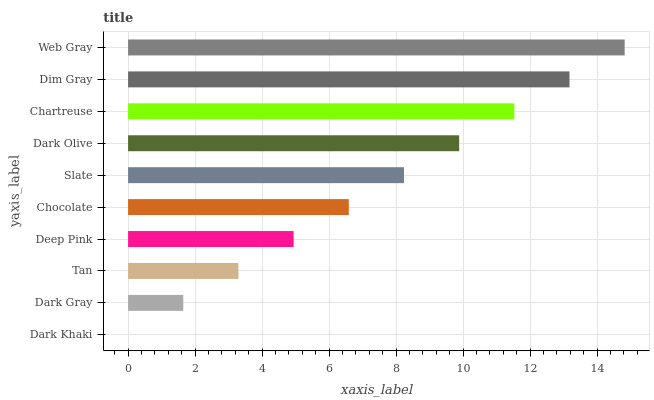Is Dark Khaki the minimum?
Answer yes or no. Yes. Is Web Gray the maximum?
Answer yes or no. Yes. Is Dark Gray the minimum?
Answer yes or no. No. Is Dark Gray the maximum?
Answer yes or no. No. Is Dark Gray greater than Dark Khaki?
Answer yes or no. Yes. Is Dark Khaki less than Dark Gray?
Answer yes or no. Yes. Is Dark Khaki greater than Dark Gray?
Answer yes or no. No. Is Dark Gray less than Dark Khaki?
Answer yes or no. No. Is Slate the high median?
Answer yes or no. Yes. Is Chocolate the low median?
Answer yes or no. Yes. Is Tan the high median?
Answer yes or no. No. Is Dim Gray the low median?
Answer yes or no. No. 